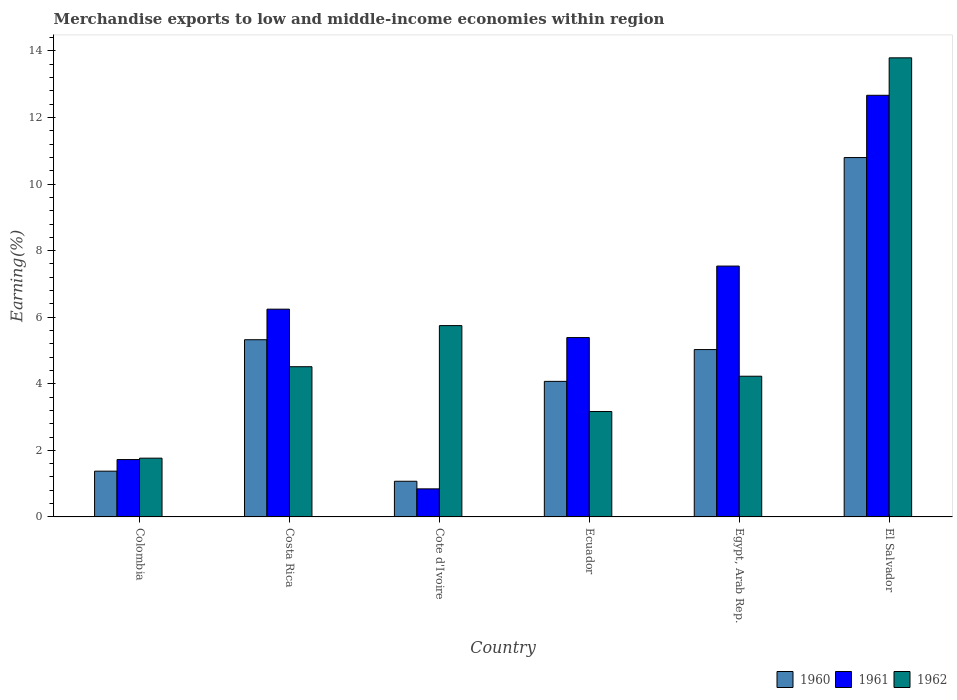How many different coloured bars are there?
Keep it short and to the point. 3. Are the number of bars per tick equal to the number of legend labels?
Offer a very short reply. Yes. How many bars are there on the 4th tick from the left?
Make the answer very short. 3. How many bars are there on the 5th tick from the right?
Make the answer very short. 3. What is the label of the 3rd group of bars from the left?
Offer a very short reply. Cote d'Ivoire. What is the percentage of amount earned from merchandise exports in 1961 in El Salvador?
Provide a short and direct response. 12.67. Across all countries, what is the maximum percentage of amount earned from merchandise exports in 1961?
Ensure brevity in your answer.  12.67. Across all countries, what is the minimum percentage of amount earned from merchandise exports in 1961?
Ensure brevity in your answer.  0.84. In which country was the percentage of amount earned from merchandise exports in 1962 maximum?
Make the answer very short. El Salvador. In which country was the percentage of amount earned from merchandise exports in 1961 minimum?
Give a very brief answer. Cote d'Ivoire. What is the total percentage of amount earned from merchandise exports in 1962 in the graph?
Offer a very short reply. 33.21. What is the difference between the percentage of amount earned from merchandise exports in 1960 in Costa Rica and that in Ecuador?
Give a very brief answer. 1.25. What is the difference between the percentage of amount earned from merchandise exports in 1962 in Costa Rica and the percentage of amount earned from merchandise exports in 1961 in Egypt, Arab Rep.?
Ensure brevity in your answer.  -3.02. What is the average percentage of amount earned from merchandise exports in 1961 per country?
Your answer should be compact. 5.73. What is the difference between the percentage of amount earned from merchandise exports of/in 1961 and percentage of amount earned from merchandise exports of/in 1960 in Costa Rica?
Offer a very short reply. 0.92. In how many countries, is the percentage of amount earned from merchandise exports in 1961 greater than 10.8 %?
Provide a short and direct response. 1. What is the ratio of the percentage of amount earned from merchandise exports in 1962 in Cote d'Ivoire to that in El Salvador?
Offer a very short reply. 0.42. Is the difference between the percentage of amount earned from merchandise exports in 1961 in Colombia and Egypt, Arab Rep. greater than the difference between the percentage of amount earned from merchandise exports in 1960 in Colombia and Egypt, Arab Rep.?
Keep it short and to the point. No. What is the difference between the highest and the second highest percentage of amount earned from merchandise exports in 1962?
Give a very brief answer. 1.24. What is the difference between the highest and the lowest percentage of amount earned from merchandise exports in 1962?
Ensure brevity in your answer.  12.03. In how many countries, is the percentage of amount earned from merchandise exports in 1962 greater than the average percentage of amount earned from merchandise exports in 1962 taken over all countries?
Provide a succinct answer. 2. Is the sum of the percentage of amount earned from merchandise exports in 1960 in Costa Rica and Egypt, Arab Rep. greater than the maximum percentage of amount earned from merchandise exports in 1961 across all countries?
Provide a succinct answer. No. What does the 2nd bar from the left in Egypt, Arab Rep. represents?
Your response must be concise. 1961. What does the 2nd bar from the right in Colombia represents?
Offer a terse response. 1961. How many countries are there in the graph?
Your response must be concise. 6. Does the graph contain grids?
Ensure brevity in your answer.  No. Where does the legend appear in the graph?
Keep it short and to the point. Bottom right. How many legend labels are there?
Make the answer very short. 3. How are the legend labels stacked?
Provide a succinct answer. Horizontal. What is the title of the graph?
Your answer should be very brief. Merchandise exports to low and middle-income economies within region. Does "1968" appear as one of the legend labels in the graph?
Your answer should be very brief. No. What is the label or title of the X-axis?
Offer a very short reply. Country. What is the label or title of the Y-axis?
Keep it short and to the point. Earning(%). What is the Earning(%) of 1960 in Colombia?
Give a very brief answer. 1.38. What is the Earning(%) of 1961 in Colombia?
Give a very brief answer. 1.72. What is the Earning(%) in 1962 in Colombia?
Ensure brevity in your answer.  1.77. What is the Earning(%) of 1960 in Costa Rica?
Keep it short and to the point. 5.32. What is the Earning(%) in 1961 in Costa Rica?
Your response must be concise. 6.24. What is the Earning(%) of 1962 in Costa Rica?
Your answer should be very brief. 4.51. What is the Earning(%) in 1960 in Cote d'Ivoire?
Offer a terse response. 1.07. What is the Earning(%) in 1961 in Cote d'Ivoire?
Keep it short and to the point. 0.84. What is the Earning(%) in 1962 in Cote d'Ivoire?
Offer a terse response. 5.75. What is the Earning(%) in 1960 in Ecuador?
Keep it short and to the point. 4.07. What is the Earning(%) in 1961 in Ecuador?
Provide a short and direct response. 5.39. What is the Earning(%) in 1962 in Ecuador?
Your answer should be compact. 3.17. What is the Earning(%) in 1960 in Egypt, Arab Rep.?
Provide a short and direct response. 5.03. What is the Earning(%) in 1961 in Egypt, Arab Rep.?
Provide a short and direct response. 7.54. What is the Earning(%) in 1962 in Egypt, Arab Rep.?
Your response must be concise. 4.23. What is the Earning(%) in 1960 in El Salvador?
Your response must be concise. 10.8. What is the Earning(%) in 1961 in El Salvador?
Keep it short and to the point. 12.67. What is the Earning(%) in 1962 in El Salvador?
Make the answer very short. 13.79. Across all countries, what is the maximum Earning(%) in 1960?
Provide a succinct answer. 10.8. Across all countries, what is the maximum Earning(%) in 1961?
Offer a very short reply. 12.67. Across all countries, what is the maximum Earning(%) of 1962?
Provide a succinct answer. 13.79. Across all countries, what is the minimum Earning(%) in 1960?
Your answer should be compact. 1.07. Across all countries, what is the minimum Earning(%) of 1961?
Your response must be concise. 0.84. Across all countries, what is the minimum Earning(%) in 1962?
Offer a very short reply. 1.77. What is the total Earning(%) in 1960 in the graph?
Provide a succinct answer. 27.67. What is the total Earning(%) of 1961 in the graph?
Provide a succinct answer. 34.4. What is the total Earning(%) of 1962 in the graph?
Offer a terse response. 33.21. What is the difference between the Earning(%) of 1960 in Colombia and that in Costa Rica?
Ensure brevity in your answer.  -3.95. What is the difference between the Earning(%) of 1961 in Colombia and that in Costa Rica?
Your response must be concise. -4.52. What is the difference between the Earning(%) in 1962 in Colombia and that in Costa Rica?
Your response must be concise. -2.75. What is the difference between the Earning(%) of 1960 in Colombia and that in Cote d'Ivoire?
Offer a very short reply. 0.3. What is the difference between the Earning(%) in 1961 in Colombia and that in Cote d'Ivoire?
Your answer should be very brief. 0.88. What is the difference between the Earning(%) in 1962 in Colombia and that in Cote d'Ivoire?
Give a very brief answer. -3.98. What is the difference between the Earning(%) in 1960 in Colombia and that in Ecuador?
Offer a terse response. -2.7. What is the difference between the Earning(%) in 1961 in Colombia and that in Ecuador?
Your answer should be compact. -3.66. What is the difference between the Earning(%) in 1962 in Colombia and that in Ecuador?
Your answer should be compact. -1.4. What is the difference between the Earning(%) in 1960 in Colombia and that in Egypt, Arab Rep.?
Provide a succinct answer. -3.65. What is the difference between the Earning(%) in 1961 in Colombia and that in Egypt, Arab Rep.?
Your answer should be compact. -5.81. What is the difference between the Earning(%) in 1962 in Colombia and that in Egypt, Arab Rep.?
Ensure brevity in your answer.  -2.46. What is the difference between the Earning(%) in 1960 in Colombia and that in El Salvador?
Give a very brief answer. -9.42. What is the difference between the Earning(%) in 1961 in Colombia and that in El Salvador?
Provide a succinct answer. -10.94. What is the difference between the Earning(%) of 1962 in Colombia and that in El Salvador?
Your answer should be compact. -12.03. What is the difference between the Earning(%) of 1960 in Costa Rica and that in Cote d'Ivoire?
Make the answer very short. 4.25. What is the difference between the Earning(%) of 1961 in Costa Rica and that in Cote d'Ivoire?
Offer a very short reply. 5.4. What is the difference between the Earning(%) of 1962 in Costa Rica and that in Cote d'Ivoire?
Provide a short and direct response. -1.24. What is the difference between the Earning(%) in 1960 in Costa Rica and that in Ecuador?
Your answer should be very brief. 1.25. What is the difference between the Earning(%) of 1961 in Costa Rica and that in Ecuador?
Provide a short and direct response. 0.85. What is the difference between the Earning(%) in 1962 in Costa Rica and that in Ecuador?
Give a very brief answer. 1.35. What is the difference between the Earning(%) in 1960 in Costa Rica and that in Egypt, Arab Rep.?
Your response must be concise. 0.3. What is the difference between the Earning(%) of 1961 in Costa Rica and that in Egypt, Arab Rep.?
Give a very brief answer. -1.29. What is the difference between the Earning(%) in 1962 in Costa Rica and that in Egypt, Arab Rep.?
Your response must be concise. 0.29. What is the difference between the Earning(%) in 1960 in Costa Rica and that in El Salvador?
Your answer should be very brief. -5.47. What is the difference between the Earning(%) of 1961 in Costa Rica and that in El Salvador?
Provide a succinct answer. -6.43. What is the difference between the Earning(%) in 1962 in Costa Rica and that in El Salvador?
Give a very brief answer. -9.28. What is the difference between the Earning(%) of 1960 in Cote d'Ivoire and that in Ecuador?
Offer a terse response. -3. What is the difference between the Earning(%) in 1961 in Cote d'Ivoire and that in Ecuador?
Provide a short and direct response. -4.55. What is the difference between the Earning(%) of 1962 in Cote d'Ivoire and that in Ecuador?
Provide a succinct answer. 2.58. What is the difference between the Earning(%) in 1960 in Cote d'Ivoire and that in Egypt, Arab Rep.?
Your answer should be compact. -3.96. What is the difference between the Earning(%) in 1961 in Cote d'Ivoire and that in Egypt, Arab Rep.?
Give a very brief answer. -6.69. What is the difference between the Earning(%) of 1962 in Cote d'Ivoire and that in Egypt, Arab Rep.?
Offer a very short reply. 1.52. What is the difference between the Earning(%) of 1960 in Cote d'Ivoire and that in El Salvador?
Offer a very short reply. -9.73. What is the difference between the Earning(%) in 1961 in Cote d'Ivoire and that in El Salvador?
Your response must be concise. -11.82. What is the difference between the Earning(%) of 1962 in Cote d'Ivoire and that in El Salvador?
Make the answer very short. -8.04. What is the difference between the Earning(%) of 1960 in Ecuador and that in Egypt, Arab Rep.?
Provide a short and direct response. -0.96. What is the difference between the Earning(%) in 1961 in Ecuador and that in Egypt, Arab Rep.?
Your answer should be very brief. -2.15. What is the difference between the Earning(%) in 1962 in Ecuador and that in Egypt, Arab Rep.?
Make the answer very short. -1.06. What is the difference between the Earning(%) in 1960 in Ecuador and that in El Salvador?
Offer a terse response. -6.72. What is the difference between the Earning(%) of 1961 in Ecuador and that in El Salvador?
Offer a terse response. -7.28. What is the difference between the Earning(%) in 1962 in Ecuador and that in El Salvador?
Provide a succinct answer. -10.63. What is the difference between the Earning(%) of 1960 in Egypt, Arab Rep. and that in El Salvador?
Provide a short and direct response. -5.77. What is the difference between the Earning(%) in 1961 in Egypt, Arab Rep. and that in El Salvador?
Provide a short and direct response. -5.13. What is the difference between the Earning(%) of 1962 in Egypt, Arab Rep. and that in El Salvador?
Your answer should be very brief. -9.57. What is the difference between the Earning(%) of 1960 in Colombia and the Earning(%) of 1961 in Costa Rica?
Your answer should be very brief. -4.87. What is the difference between the Earning(%) of 1960 in Colombia and the Earning(%) of 1962 in Costa Rica?
Keep it short and to the point. -3.14. What is the difference between the Earning(%) of 1961 in Colombia and the Earning(%) of 1962 in Costa Rica?
Your answer should be compact. -2.79. What is the difference between the Earning(%) of 1960 in Colombia and the Earning(%) of 1961 in Cote d'Ivoire?
Offer a very short reply. 0.53. What is the difference between the Earning(%) of 1960 in Colombia and the Earning(%) of 1962 in Cote d'Ivoire?
Ensure brevity in your answer.  -4.37. What is the difference between the Earning(%) of 1961 in Colombia and the Earning(%) of 1962 in Cote d'Ivoire?
Offer a terse response. -4.02. What is the difference between the Earning(%) of 1960 in Colombia and the Earning(%) of 1961 in Ecuador?
Offer a terse response. -4.01. What is the difference between the Earning(%) of 1960 in Colombia and the Earning(%) of 1962 in Ecuador?
Keep it short and to the point. -1.79. What is the difference between the Earning(%) of 1961 in Colombia and the Earning(%) of 1962 in Ecuador?
Your answer should be very brief. -1.44. What is the difference between the Earning(%) of 1960 in Colombia and the Earning(%) of 1961 in Egypt, Arab Rep.?
Provide a succinct answer. -6.16. What is the difference between the Earning(%) in 1960 in Colombia and the Earning(%) in 1962 in Egypt, Arab Rep.?
Keep it short and to the point. -2.85. What is the difference between the Earning(%) in 1961 in Colombia and the Earning(%) in 1962 in Egypt, Arab Rep.?
Keep it short and to the point. -2.5. What is the difference between the Earning(%) of 1960 in Colombia and the Earning(%) of 1961 in El Salvador?
Give a very brief answer. -11.29. What is the difference between the Earning(%) of 1960 in Colombia and the Earning(%) of 1962 in El Salvador?
Keep it short and to the point. -12.42. What is the difference between the Earning(%) of 1961 in Colombia and the Earning(%) of 1962 in El Salvador?
Make the answer very short. -12.07. What is the difference between the Earning(%) of 1960 in Costa Rica and the Earning(%) of 1961 in Cote d'Ivoire?
Make the answer very short. 4.48. What is the difference between the Earning(%) of 1960 in Costa Rica and the Earning(%) of 1962 in Cote d'Ivoire?
Your response must be concise. -0.42. What is the difference between the Earning(%) of 1961 in Costa Rica and the Earning(%) of 1962 in Cote d'Ivoire?
Your response must be concise. 0.49. What is the difference between the Earning(%) in 1960 in Costa Rica and the Earning(%) in 1961 in Ecuador?
Your response must be concise. -0.06. What is the difference between the Earning(%) of 1960 in Costa Rica and the Earning(%) of 1962 in Ecuador?
Your response must be concise. 2.16. What is the difference between the Earning(%) in 1961 in Costa Rica and the Earning(%) in 1962 in Ecuador?
Give a very brief answer. 3.07. What is the difference between the Earning(%) of 1960 in Costa Rica and the Earning(%) of 1961 in Egypt, Arab Rep.?
Offer a very short reply. -2.21. What is the difference between the Earning(%) of 1960 in Costa Rica and the Earning(%) of 1962 in Egypt, Arab Rep.?
Your answer should be very brief. 1.1. What is the difference between the Earning(%) in 1961 in Costa Rica and the Earning(%) in 1962 in Egypt, Arab Rep.?
Make the answer very short. 2.02. What is the difference between the Earning(%) in 1960 in Costa Rica and the Earning(%) in 1961 in El Salvador?
Ensure brevity in your answer.  -7.34. What is the difference between the Earning(%) of 1960 in Costa Rica and the Earning(%) of 1962 in El Salvador?
Your answer should be compact. -8.47. What is the difference between the Earning(%) in 1961 in Costa Rica and the Earning(%) in 1962 in El Salvador?
Your answer should be very brief. -7.55. What is the difference between the Earning(%) of 1960 in Cote d'Ivoire and the Earning(%) of 1961 in Ecuador?
Provide a short and direct response. -4.32. What is the difference between the Earning(%) in 1960 in Cote d'Ivoire and the Earning(%) in 1962 in Ecuador?
Offer a terse response. -2.1. What is the difference between the Earning(%) in 1961 in Cote d'Ivoire and the Earning(%) in 1962 in Ecuador?
Your answer should be very brief. -2.32. What is the difference between the Earning(%) of 1960 in Cote d'Ivoire and the Earning(%) of 1961 in Egypt, Arab Rep.?
Your response must be concise. -6.47. What is the difference between the Earning(%) of 1960 in Cote d'Ivoire and the Earning(%) of 1962 in Egypt, Arab Rep.?
Your response must be concise. -3.16. What is the difference between the Earning(%) in 1961 in Cote d'Ivoire and the Earning(%) in 1962 in Egypt, Arab Rep.?
Your response must be concise. -3.38. What is the difference between the Earning(%) of 1960 in Cote d'Ivoire and the Earning(%) of 1961 in El Salvador?
Offer a terse response. -11.6. What is the difference between the Earning(%) in 1960 in Cote d'Ivoire and the Earning(%) in 1962 in El Salvador?
Keep it short and to the point. -12.72. What is the difference between the Earning(%) of 1961 in Cote d'Ivoire and the Earning(%) of 1962 in El Salvador?
Make the answer very short. -12.95. What is the difference between the Earning(%) in 1960 in Ecuador and the Earning(%) in 1961 in Egypt, Arab Rep.?
Give a very brief answer. -3.46. What is the difference between the Earning(%) in 1960 in Ecuador and the Earning(%) in 1962 in Egypt, Arab Rep.?
Provide a short and direct response. -0.15. What is the difference between the Earning(%) in 1961 in Ecuador and the Earning(%) in 1962 in Egypt, Arab Rep.?
Make the answer very short. 1.16. What is the difference between the Earning(%) of 1960 in Ecuador and the Earning(%) of 1961 in El Salvador?
Your answer should be very brief. -8.59. What is the difference between the Earning(%) of 1960 in Ecuador and the Earning(%) of 1962 in El Salvador?
Your answer should be very brief. -9.72. What is the difference between the Earning(%) of 1961 in Ecuador and the Earning(%) of 1962 in El Salvador?
Your answer should be compact. -8.4. What is the difference between the Earning(%) in 1960 in Egypt, Arab Rep. and the Earning(%) in 1961 in El Salvador?
Provide a succinct answer. -7.64. What is the difference between the Earning(%) in 1960 in Egypt, Arab Rep. and the Earning(%) in 1962 in El Salvador?
Your answer should be very brief. -8.76. What is the difference between the Earning(%) of 1961 in Egypt, Arab Rep. and the Earning(%) of 1962 in El Salvador?
Ensure brevity in your answer.  -6.26. What is the average Earning(%) of 1960 per country?
Your response must be concise. 4.61. What is the average Earning(%) in 1961 per country?
Offer a very short reply. 5.73. What is the average Earning(%) of 1962 per country?
Keep it short and to the point. 5.54. What is the difference between the Earning(%) of 1960 and Earning(%) of 1961 in Colombia?
Provide a succinct answer. -0.35. What is the difference between the Earning(%) in 1960 and Earning(%) in 1962 in Colombia?
Make the answer very short. -0.39. What is the difference between the Earning(%) in 1961 and Earning(%) in 1962 in Colombia?
Keep it short and to the point. -0.04. What is the difference between the Earning(%) in 1960 and Earning(%) in 1961 in Costa Rica?
Your response must be concise. -0.92. What is the difference between the Earning(%) in 1960 and Earning(%) in 1962 in Costa Rica?
Ensure brevity in your answer.  0.81. What is the difference between the Earning(%) in 1961 and Earning(%) in 1962 in Costa Rica?
Offer a terse response. 1.73. What is the difference between the Earning(%) of 1960 and Earning(%) of 1961 in Cote d'Ivoire?
Your answer should be very brief. 0.23. What is the difference between the Earning(%) of 1960 and Earning(%) of 1962 in Cote d'Ivoire?
Your answer should be compact. -4.68. What is the difference between the Earning(%) of 1961 and Earning(%) of 1962 in Cote d'Ivoire?
Provide a succinct answer. -4.91. What is the difference between the Earning(%) of 1960 and Earning(%) of 1961 in Ecuador?
Your answer should be compact. -1.32. What is the difference between the Earning(%) in 1960 and Earning(%) in 1962 in Ecuador?
Keep it short and to the point. 0.91. What is the difference between the Earning(%) of 1961 and Earning(%) of 1962 in Ecuador?
Your answer should be very brief. 2.22. What is the difference between the Earning(%) in 1960 and Earning(%) in 1961 in Egypt, Arab Rep.?
Give a very brief answer. -2.51. What is the difference between the Earning(%) in 1960 and Earning(%) in 1962 in Egypt, Arab Rep.?
Your answer should be very brief. 0.8. What is the difference between the Earning(%) of 1961 and Earning(%) of 1962 in Egypt, Arab Rep.?
Provide a succinct answer. 3.31. What is the difference between the Earning(%) in 1960 and Earning(%) in 1961 in El Salvador?
Your answer should be very brief. -1.87. What is the difference between the Earning(%) in 1960 and Earning(%) in 1962 in El Salvador?
Your answer should be compact. -3. What is the difference between the Earning(%) of 1961 and Earning(%) of 1962 in El Salvador?
Offer a terse response. -1.13. What is the ratio of the Earning(%) of 1960 in Colombia to that in Costa Rica?
Keep it short and to the point. 0.26. What is the ratio of the Earning(%) in 1961 in Colombia to that in Costa Rica?
Give a very brief answer. 0.28. What is the ratio of the Earning(%) of 1962 in Colombia to that in Costa Rica?
Offer a very short reply. 0.39. What is the ratio of the Earning(%) in 1960 in Colombia to that in Cote d'Ivoire?
Your response must be concise. 1.28. What is the ratio of the Earning(%) of 1961 in Colombia to that in Cote d'Ivoire?
Make the answer very short. 2.04. What is the ratio of the Earning(%) of 1962 in Colombia to that in Cote d'Ivoire?
Provide a succinct answer. 0.31. What is the ratio of the Earning(%) in 1960 in Colombia to that in Ecuador?
Offer a terse response. 0.34. What is the ratio of the Earning(%) in 1961 in Colombia to that in Ecuador?
Keep it short and to the point. 0.32. What is the ratio of the Earning(%) in 1962 in Colombia to that in Ecuador?
Offer a very short reply. 0.56. What is the ratio of the Earning(%) in 1960 in Colombia to that in Egypt, Arab Rep.?
Provide a short and direct response. 0.27. What is the ratio of the Earning(%) in 1961 in Colombia to that in Egypt, Arab Rep.?
Give a very brief answer. 0.23. What is the ratio of the Earning(%) in 1962 in Colombia to that in Egypt, Arab Rep.?
Make the answer very short. 0.42. What is the ratio of the Earning(%) in 1960 in Colombia to that in El Salvador?
Make the answer very short. 0.13. What is the ratio of the Earning(%) in 1961 in Colombia to that in El Salvador?
Keep it short and to the point. 0.14. What is the ratio of the Earning(%) of 1962 in Colombia to that in El Salvador?
Ensure brevity in your answer.  0.13. What is the ratio of the Earning(%) in 1960 in Costa Rica to that in Cote d'Ivoire?
Provide a short and direct response. 4.97. What is the ratio of the Earning(%) of 1961 in Costa Rica to that in Cote d'Ivoire?
Provide a short and direct response. 7.4. What is the ratio of the Earning(%) in 1962 in Costa Rica to that in Cote d'Ivoire?
Give a very brief answer. 0.79. What is the ratio of the Earning(%) of 1960 in Costa Rica to that in Ecuador?
Provide a short and direct response. 1.31. What is the ratio of the Earning(%) of 1961 in Costa Rica to that in Ecuador?
Your response must be concise. 1.16. What is the ratio of the Earning(%) of 1962 in Costa Rica to that in Ecuador?
Your response must be concise. 1.42. What is the ratio of the Earning(%) in 1960 in Costa Rica to that in Egypt, Arab Rep.?
Your answer should be very brief. 1.06. What is the ratio of the Earning(%) of 1961 in Costa Rica to that in Egypt, Arab Rep.?
Give a very brief answer. 0.83. What is the ratio of the Earning(%) of 1962 in Costa Rica to that in Egypt, Arab Rep.?
Offer a terse response. 1.07. What is the ratio of the Earning(%) of 1960 in Costa Rica to that in El Salvador?
Offer a very short reply. 0.49. What is the ratio of the Earning(%) in 1961 in Costa Rica to that in El Salvador?
Your answer should be very brief. 0.49. What is the ratio of the Earning(%) of 1962 in Costa Rica to that in El Salvador?
Provide a succinct answer. 0.33. What is the ratio of the Earning(%) of 1960 in Cote d'Ivoire to that in Ecuador?
Your response must be concise. 0.26. What is the ratio of the Earning(%) in 1961 in Cote d'Ivoire to that in Ecuador?
Provide a succinct answer. 0.16. What is the ratio of the Earning(%) in 1962 in Cote d'Ivoire to that in Ecuador?
Your response must be concise. 1.81. What is the ratio of the Earning(%) in 1960 in Cote d'Ivoire to that in Egypt, Arab Rep.?
Provide a succinct answer. 0.21. What is the ratio of the Earning(%) of 1961 in Cote d'Ivoire to that in Egypt, Arab Rep.?
Your response must be concise. 0.11. What is the ratio of the Earning(%) in 1962 in Cote d'Ivoire to that in Egypt, Arab Rep.?
Offer a terse response. 1.36. What is the ratio of the Earning(%) of 1960 in Cote d'Ivoire to that in El Salvador?
Offer a very short reply. 0.1. What is the ratio of the Earning(%) of 1961 in Cote d'Ivoire to that in El Salvador?
Make the answer very short. 0.07. What is the ratio of the Earning(%) of 1962 in Cote d'Ivoire to that in El Salvador?
Provide a short and direct response. 0.42. What is the ratio of the Earning(%) in 1960 in Ecuador to that in Egypt, Arab Rep.?
Your response must be concise. 0.81. What is the ratio of the Earning(%) of 1961 in Ecuador to that in Egypt, Arab Rep.?
Your answer should be very brief. 0.71. What is the ratio of the Earning(%) in 1962 in Ecuador to that in Egypt, Arab Rep.?
Your answer should be very brief. 0.75. What is the ratio of the Earning(%) of 1960 in Ecuador to that in El Salvador?
Offer a very short reply. 0.38. What is the ratio of the Earning(%) of 1961 in Ecuador to that in El Salvador?
Your response must be concise. 0.43. What is the ratio of the Earning(%) of 1962 in Ecuador to that in El Salvador?
Your response must be concise. 0.23. What is the ratio of the Earning(%) of 1960 in Egypt, Arab Rep. to that in El Salvador?
Provide a short and direct response. 0.47. What is the ratio of the Earning(%) of 1961 in Egypt, Arab Rep. to that in El Salvador?
Your response must be concise. 0.59. What is the ratio of the Earning(%) in 1962 in Egypt, Arab Rep. to that in El Salvador?
Your answer should be very brief. 0.31. What is the difference between the highest and the second highest Earning(%) in 1960?
Ensure brevity in your answer.  5.47. What is the difference between the highest and the second highest Earning(%) in 1961?
Ensure brevity in your answer.  5.13. What is the difference between the highest and the second highest Earning(%) in 1962?
Offer a terse response. 8.04. What is the difference between the highest and the lowest Earning(%) of 1960?
Your answer should be very brief. 9.73. What is the difference between the highest and the lowest Earning(%) in 1961?
Make the answer very short. 11.82. What is the difference between the highest and the lowest Earning(%) of 1962?
Make the answer very short. 12.03. 